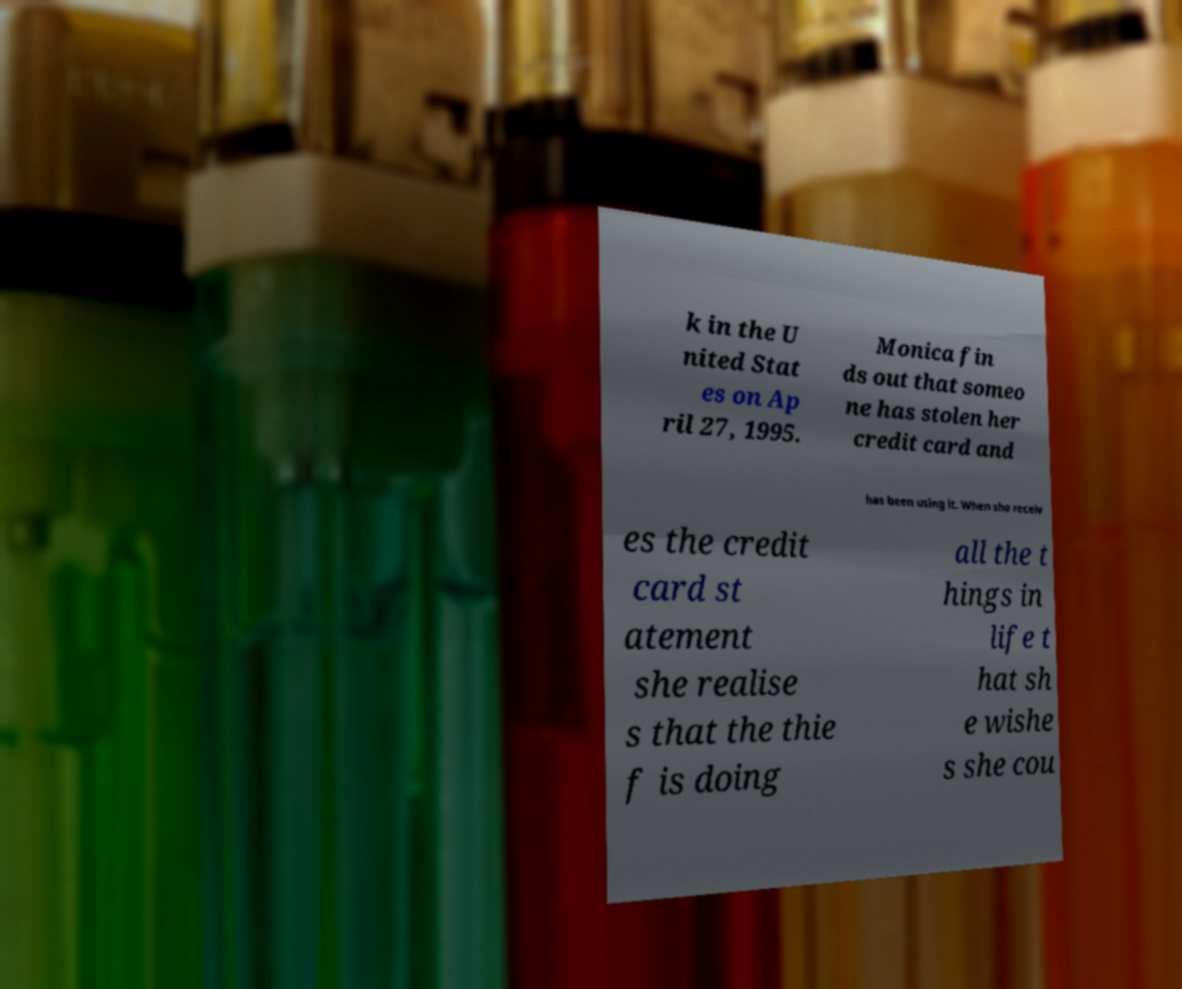Please read and relay the text visible in this image. What does it say? k in the U nited Stat es on Ap ril 27, 1995. Monica fin ds out that someo ne has stolen her credit card and has been using it. When she receiv es the credit card st atement she realise s that the thie f is doing all the t hings in life t hat sh e wishe s she cou 